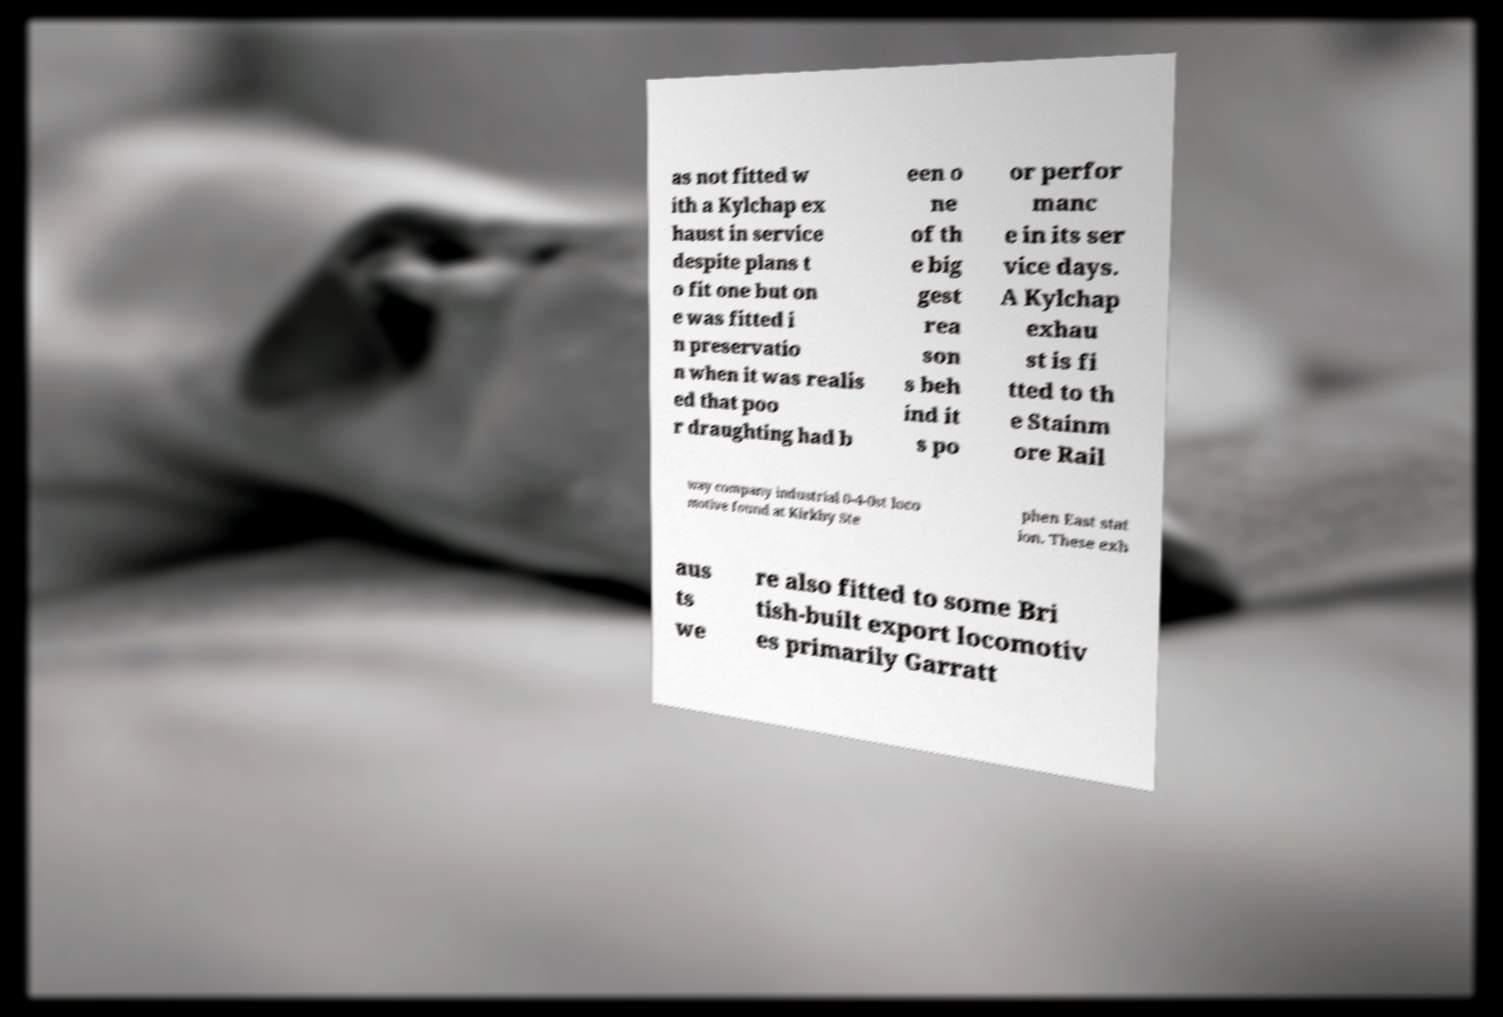I need the written content from this picture converted into text. Can you do that? as not fitted w ith a Kylchap ex haust in service despite plans t o fit one but on e was fitted i n preservatio n when it was realis ed that poo r draughting had b een o ne of th e big gest rea son s beh ind it s po or perfor manc e in its ser vice days. A Kylchap exhau st is fi tted to th e Stainm ore Rail way company industrial 0-4-0st loco motive found at Kirkby Ste phen East stat ion. These exh aus ts we re also fitted to some Bri tish-built export locomotiv es primarily Garratt 